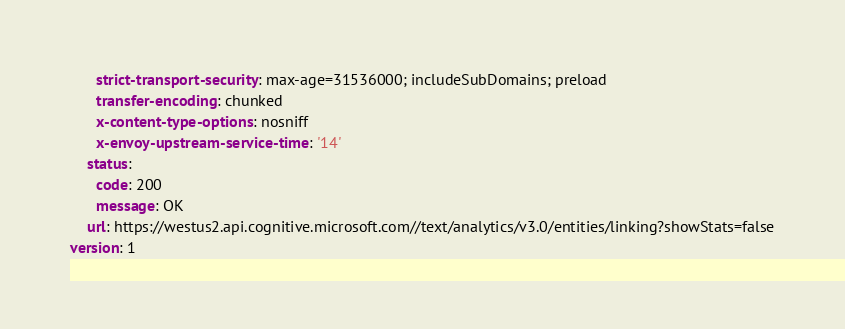Convert code to text. <code><loc_0><loc_0><loc_500><loc_500><_YAML_>      strict-transport-security: max-age=31536000; includeSubDomains; preload
      transfer-encoding: chunked
      x-content-type-options: nosniff
      x-envoy-upstream-service-time: '14'
    status:
      code: 200
      message: OK
    url: https://westus2.api.cognitive.microsoft.com//text/analytics/v3.0/entities/linking?showStats=false
version: 1
</code> 